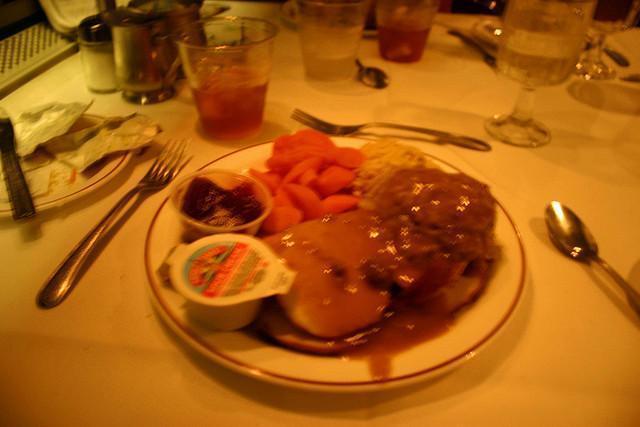How many forks are there?
Give a very brief answer. 2. How many cups are there?
Give a very brief answer. 5. 